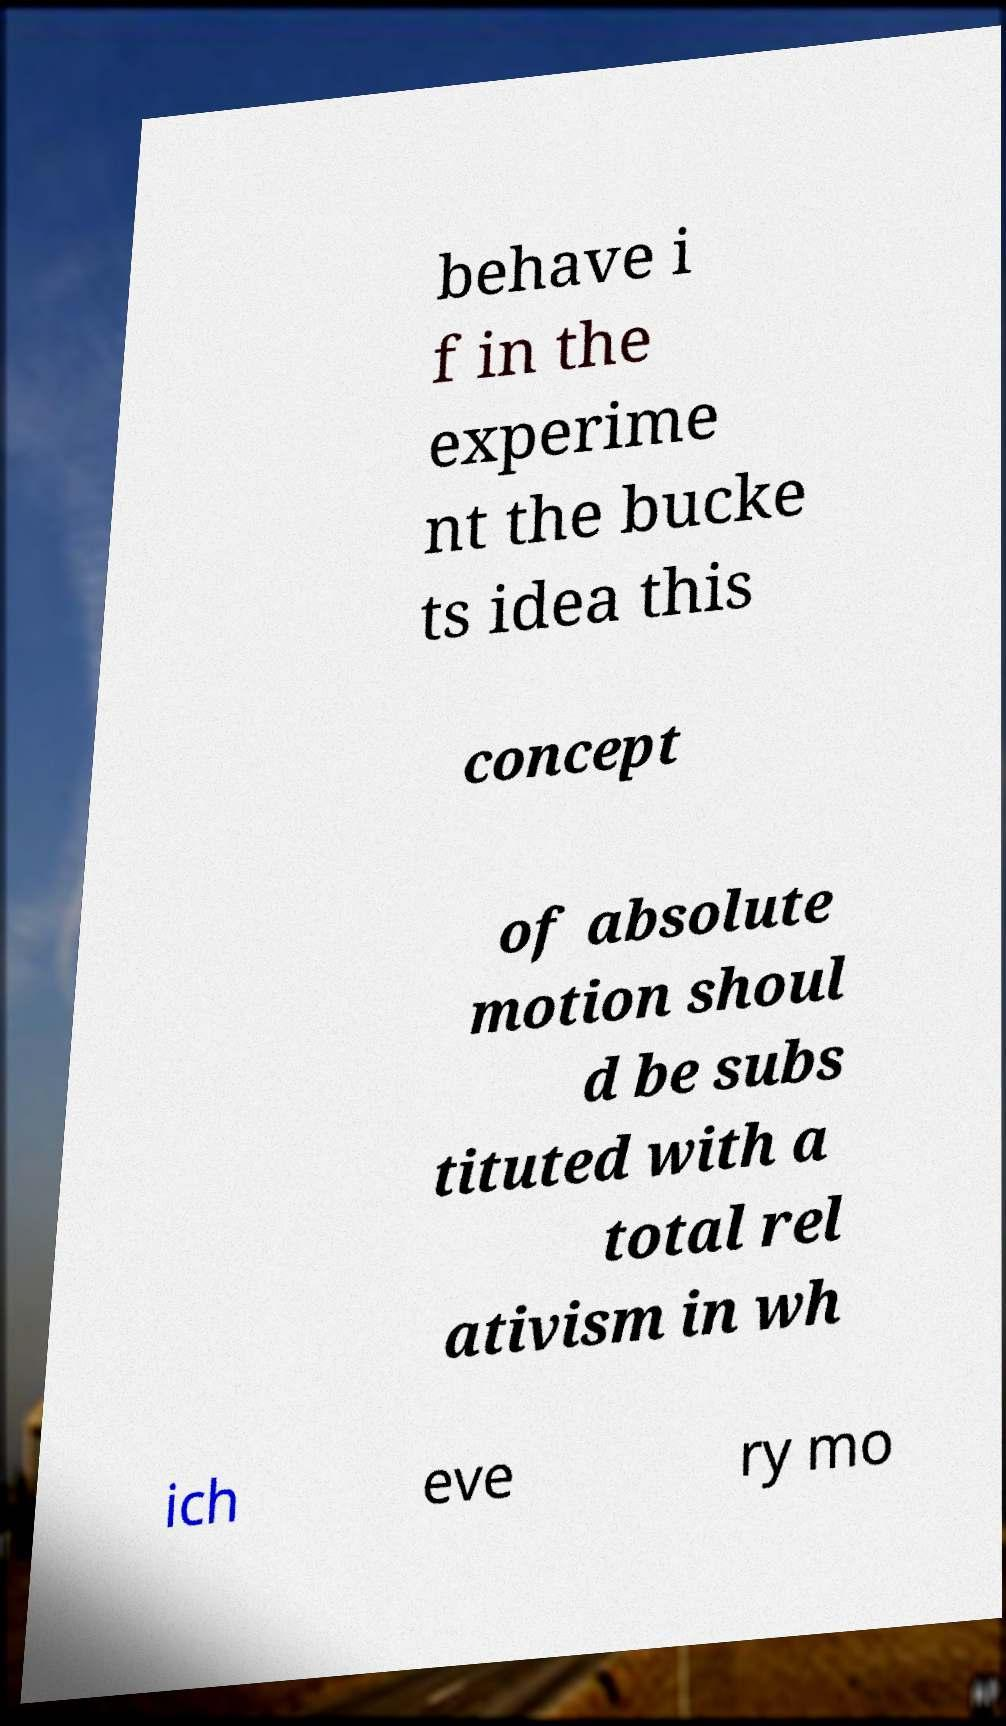What messages or text are displayed in this image? I need them in a readable, typed format. behave i f in the experime nt the bucke ts idea this concept of absolute motion shoul d be subs tituted with a total rel ativism in wh ich eve ry mo 